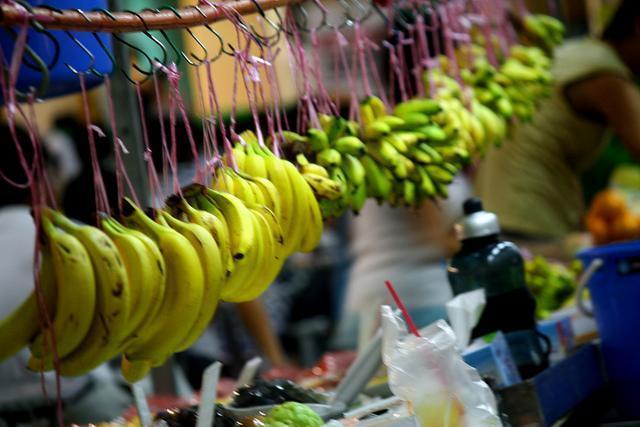How many bananas can be seen?
Give a very brief answer. 3. How many people are visible?
Give a very brief answer. 2. How many black cars are there?
Give a very brief answer. 0. 